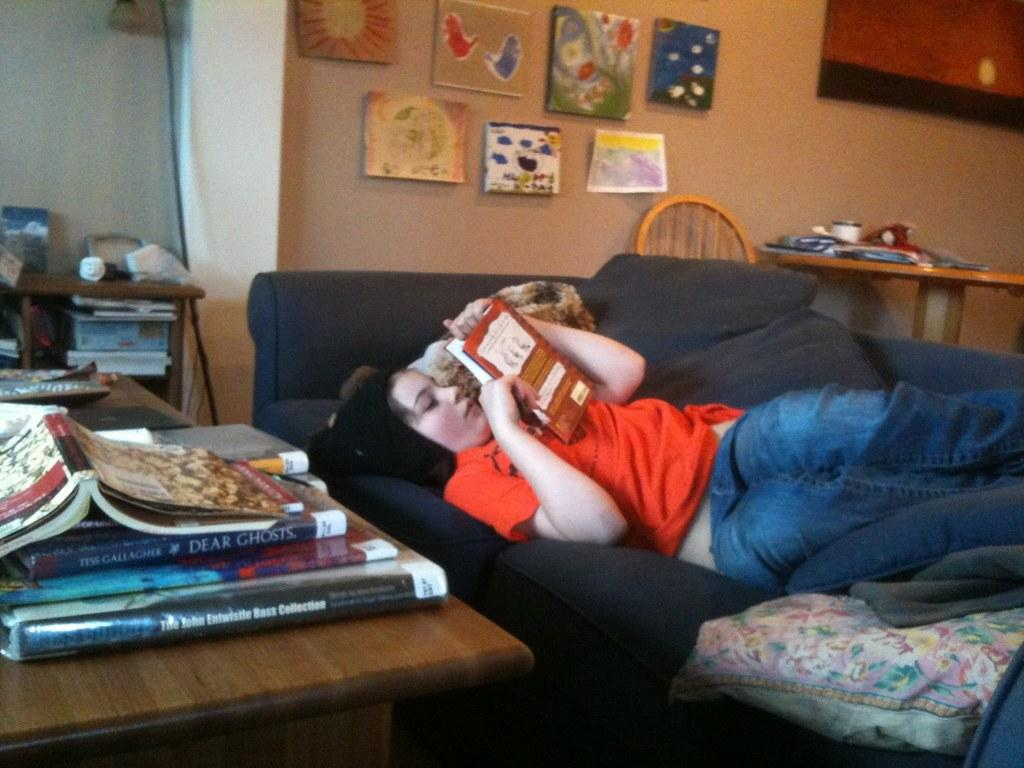Provide a one-sentence caption for the provided image. Girl reading a book while a book called "Dear Ghosts" rests on a desk next to her. 